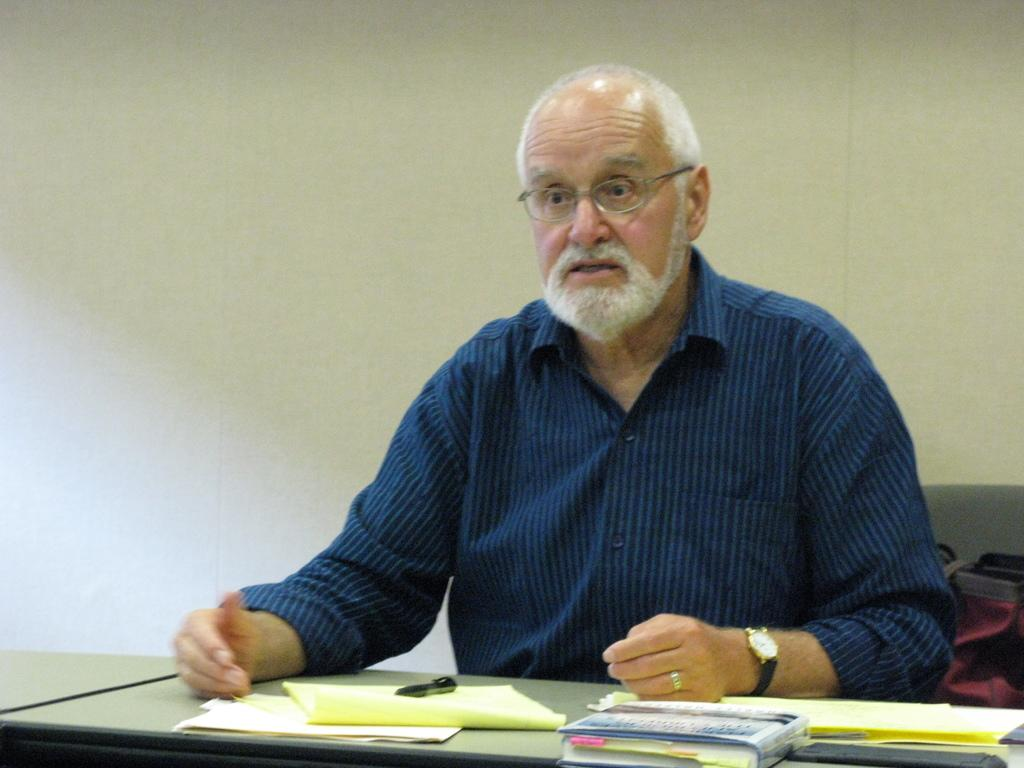What is the man in the image doing? The man is sitting in the image. What is the man wearing? The man is wearing a shirt and spectacles. What objects are on the table in the image? There are papers and books on the table. What is visible behind the man in the image? There is a wall behind the man. What type of horn can be seen on the wall in the image? There is no horn present on the wall in the image. What room is the man sitting in? The provided facts do not specify the room or location where the man is sitting. 